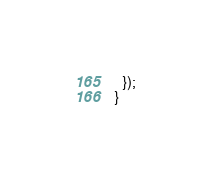Convert code to text. <code><loc_0><loc_0><loc_500><loc_500><_TypeScript_>  });
}
</code> 